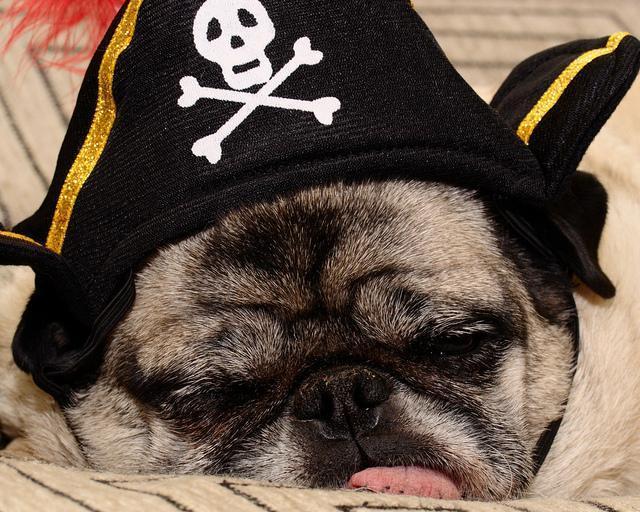How many dogs can you see?
Give a very brief answer. 2. 